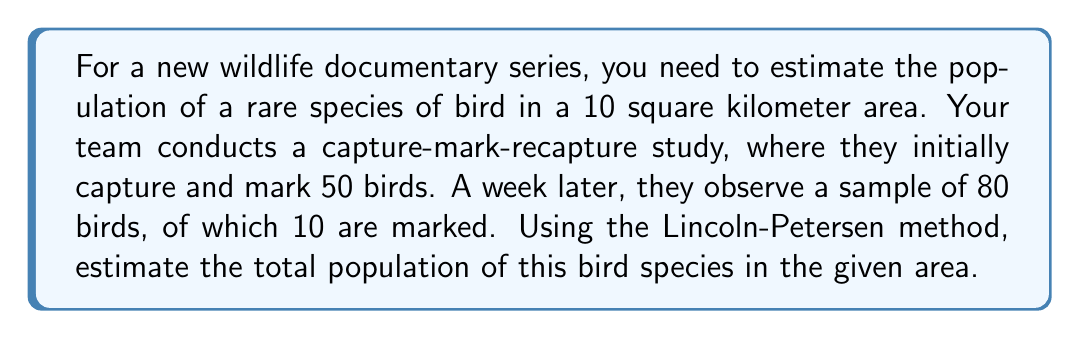Can you solve this math problem? To estimate the population size using the Lincoln-Petersen method, we follow these steps:

1. Define the variables:
   $M$ = number of individuals marked in the first capture
   $C$ = total number of individuals captured in the second sample
   $R$ = number of marked individuals recaptured in the second sample
   $N$ = estimated total population size

2. The Lincoln-Petersen formula is:

   $$N = \frac{MC}{R}$$

3. Plug in the given values:
   $M = 50$ (initially marked birds)
   $C = 80$ (total birds in second sample)
   $R = 10$ (marked birds in second sample)

4. Calculate the estimated population size:

   $$N = \frac{50 \times 80}{10} = \frac{4000}{10} = 400$$

5. Therefore, the estimated population of the rare bird species in the 10 square kilometer area is 400 individuals.

Note: This method assumes a closed population (no births, deaths, immigration, or emigration) and that all individuals have an equal chance of being captured. It also assumes that marks are not lost and that marking does not affect the animals' behavior or survival.
Answer: 400 birds 